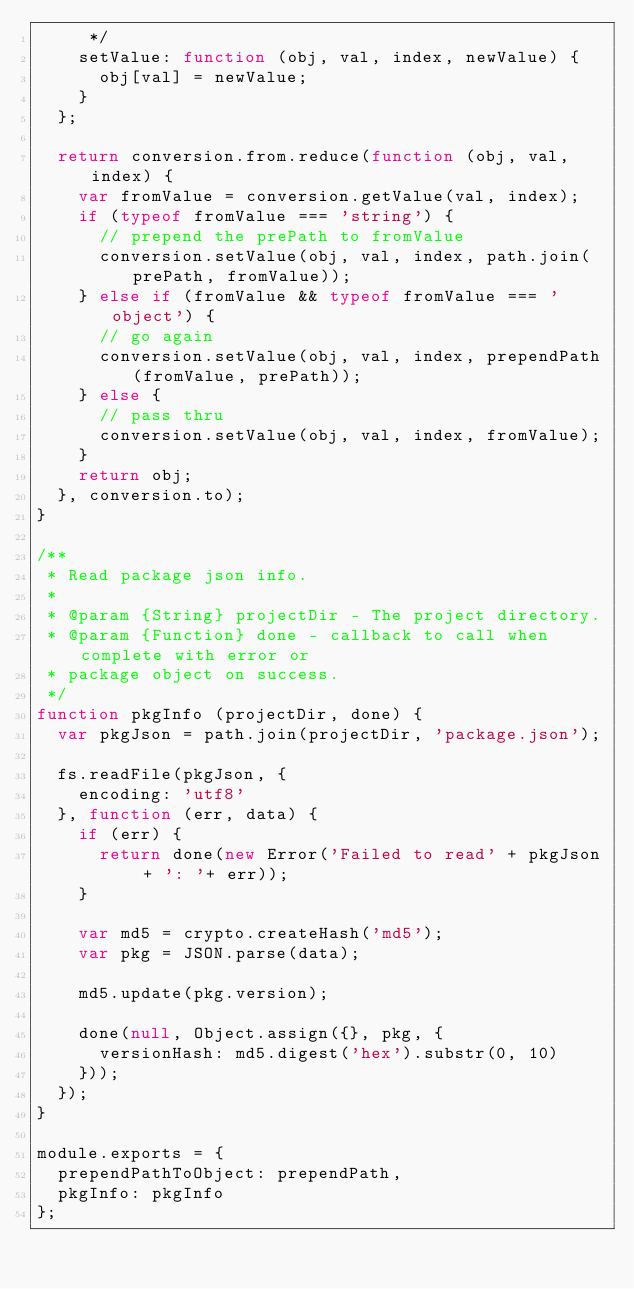Convert code to text. <code><loc_0><loc_0><loc_500><loc_500><_JavaScript_>     */
    setValue: function (obj, val, index, newValue) {
      obj[val] = newValue;
    }
  };

  return conversion.from.reduce(function (obj, val, index) {
    var fromValue = conversion.getValue(val, index);
    if (typeof fromValue === 'string') {
      // prepend the prePath to fromValue
      conversion.setValue(obj, val, index, path.join(prePath, fromValue));
    } else if (fromValue && typeof fromValue === 'object') {
      // go again
      conversion.setValue(obj, val, index, prependPath(fromValue, prePath));
    } else {
      // pass thru
      conversion.setValue(obj, val, index, fromValue);
    }
    return obj;
  }, conversion.to);
}

/**
 * Read package json info.
 *
 * @param {String} projectDir - The project directory.
 * @param {Function} done - callback to call when complete with error or
 * package object on success.
 */
function pkgInfo (projectDir, done) {
  var pkgJson = path.join(projectDir, 'package.json');

  fs.readFile(pkgJson, {
    encoding: 'utf8'
  }, function (err, data) {
    if (err) {
      return done(new Error('Failed to read' + pkgJson + ': '+ err));
    }

    var md5 = crypto.createHash('md5');
    var pkg = JSON.parse(data);

    md5.update(pkg.version);

    done(null, Object.assign({}, pkg, {
      versionHash: md5.digest('hex').substr(0, 10)
    }));
  });
}

module.exports = {
  prependPathToObject: prependPath,
  pkgInfo: pkgInfo
};
</code> 